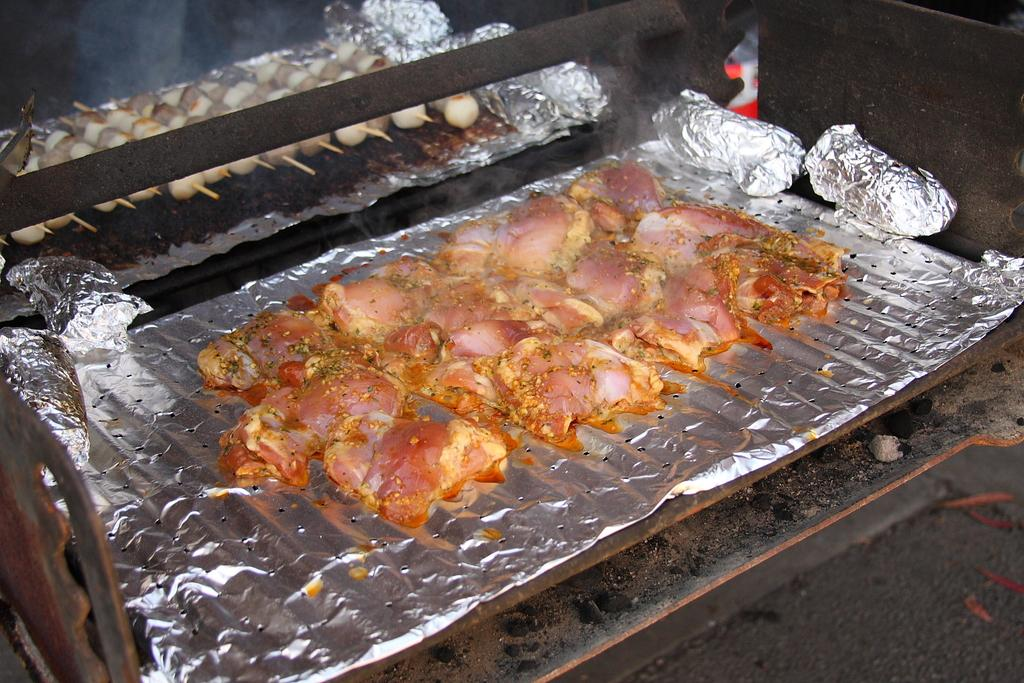What is the food placed on in the image? The food is placed on aluminium foil on a grill. What other objects made of aluminium can be seen in the image? There are aluminium balls visible in the image. Can you describe the food preparation method in the background of the image? There is food on skewers in the background of the image. What direction is the yoke pointing in the image? There is no yoke present in the image. What process is being used to cook the food in the image? The provided facts do not specify the cooking process; only the placement of the food on aluminium foil and the presence of food on skewers are mentioned. 